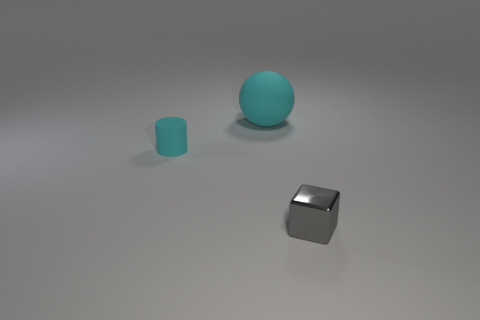Add 3 metallic objects. How many objects exist? 6 Subtract all balls. How many objects are left? 2 Subtract all tiny cylinders. Subtract all large cyan things. How many objects are left? 1 Add 3 large cyan matte balls. How many large cyan matte balls are left? 4 Add 3 tiny purple cylinders. How many tiny purple cylinders exist? 3 Subtract 1 cyan cylinders. How many objects are left? 2 